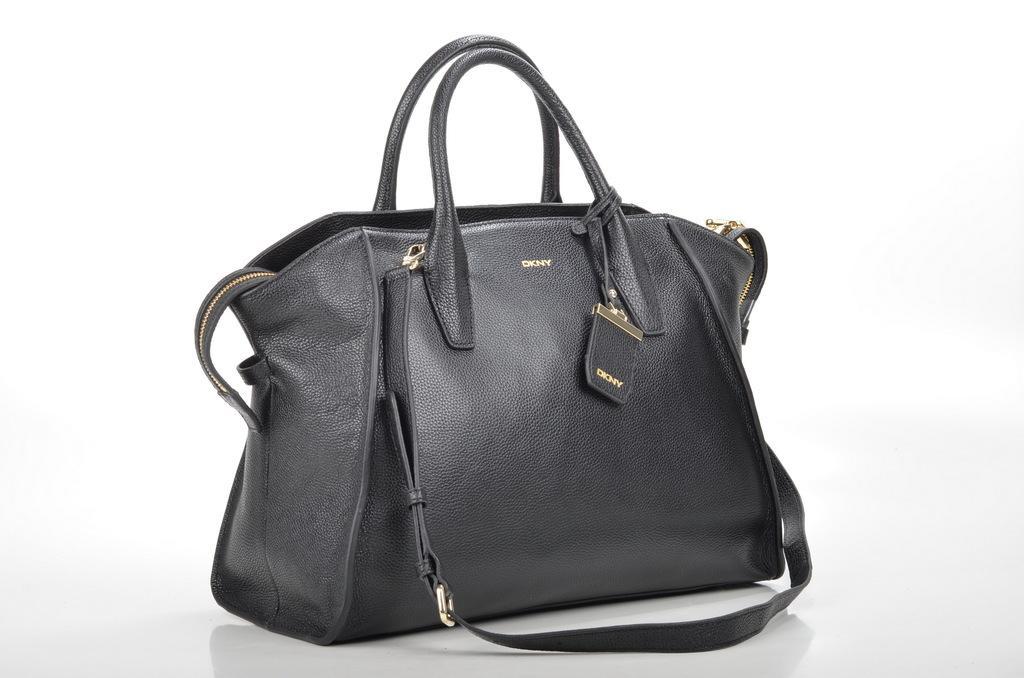In one or two sentences, can you explain what this image depicts? There is a black bag in the photo. It has a black strap. On the bag it is written DKNY. 